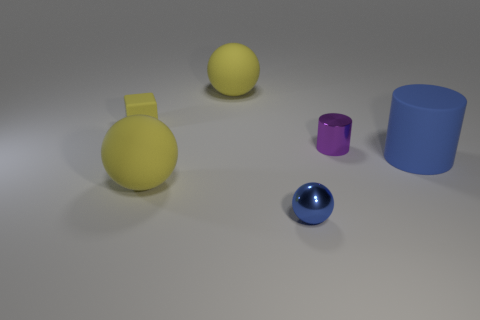Add 1 brown matte balls. How many objects exist? 7 Subtract all tiny metallic spheres. How many spheres are left? 2 Subtract all purple cubes. How many yellow spheres are left? 2 Subtract all cylinders. How many objects are left? 4 Add 2 tiny metal cylinders. How many tiny metal cylinders are left? 3 Add 6 matte cubes. How many matte cubes exist? 7 Subtract 0 purple blocks. How many objects are left? 6 Subtract all purple spheres. Subtract all green cylinders. How many spheres are left? 3 Subtract all yellow matte spheres. Subtract all blue rubber cylinders. How many objects are left? 3 